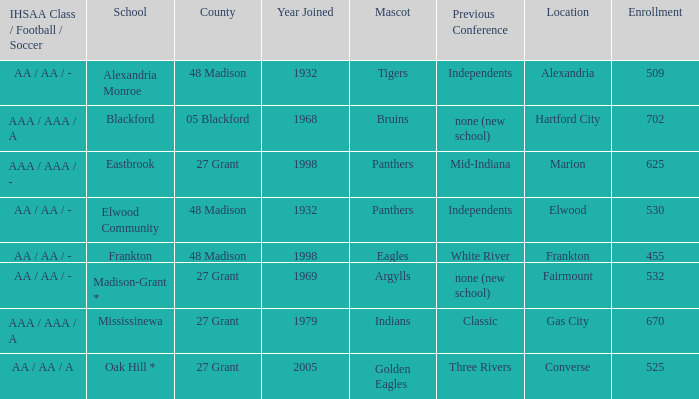Can you give me this table as a dict? {'header': ['IHSAA Class / Football / Soccer', 'School', 'County', 'Year Joined', 'Mascot', 'Previous Conference', 'Location', 'Enrollment'], 'rows': [['AA / AA / -', 'Alexandria Monroe', '48 Madison', '1932', 'Tigers', 'Independents', 'Alexandria', '509'], ['AAA / AAA / A', 'Blackford', '05 Blackford', '1968', 'Bruins', 'none (new school)', 'Hartford City', '702'], ['AAA / AAA / -', 'Eastbrook', '27 Grant', '1998', 'Panthers', 'Mid-Indiana', 'Marion', '625'], ['AA / AA / -', 'Elwood Community', '48 Madison', '1932', 'Panthers', 'Independents', 'Elwood', '530'], ['AA / AA / -', 'Frankton', '48 Madison', '1998', 'Eagles', 'White River', 'Frankton', '455'], ['AA / AA / -', 'Madison-Grant *', '27 Grant', '1969', 'Argylls', 'none (new school)', 'Fairmount', '532'], ['AAA / AAA / A', 'Mississinewa', '27 Grant', '1979', 'Indians', 'Classic', 'Gas City', '670'], ['AA / AA / A', 'Oak Hill *', '27 Grant', '2005', 'Golden Eagles', 'Three Rivers', 'Converse', '525']]} What is teh ihsaa class/football/soccer when the location is alexandria? AA / AA / -. 